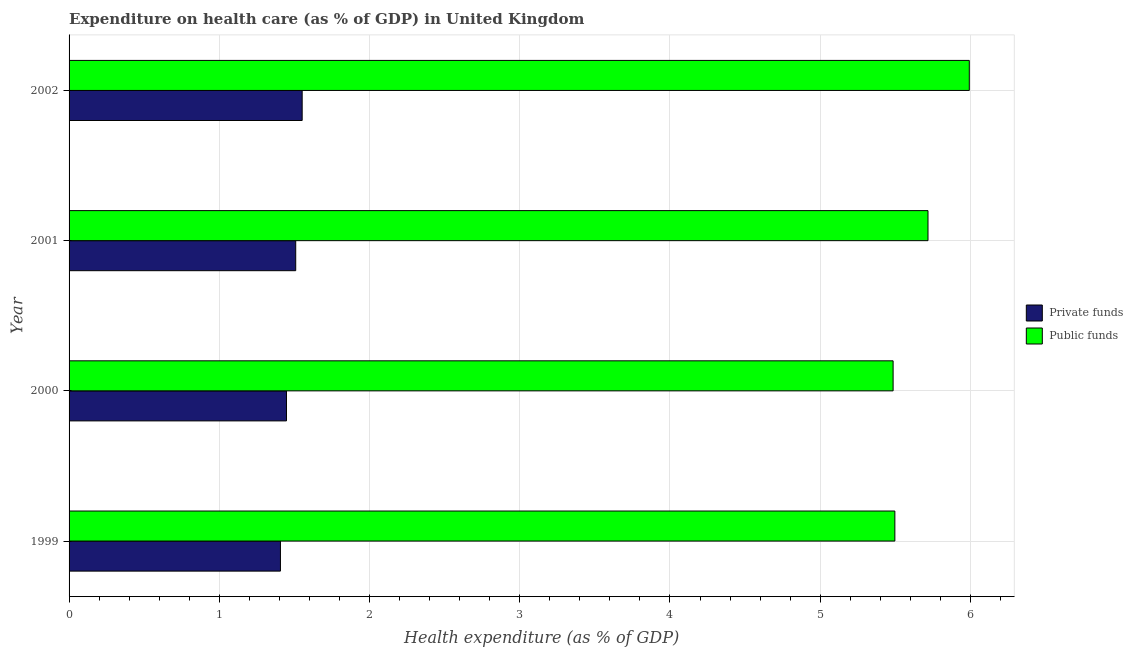How many different coloured bars are there?
Make the answer very short. 2. How many groups of bars are there?
Ensure brevity in your answer.  4. Are the number of bars on each tick of the Y-axis equal?
Make the answer very short. Yes. How many bars are there on the 4th tick from the top?
Offer a terse response. 2. How many bars are there on the 4th tick from the bottom?
Provide a short and direct response. 2. In how many cases, is the number of bars for a given year not equal to the number of legend labels?
Provide a succinct answer. 0. What is the amount of private funds spent in healthcare in 2001?
Offer a terse response. 1.51. Across all years, what is the maximum amount of public funds spent in healthcare?
Your answer should be compact. 5.99. Across all years, what is the minimum amount of public funds spent in healthcare?
Keep it short and to the point. 5.49. In which year was the amount of private funds spent in healthcare maximum?
Your answer should be very brief. 2002. What is the total amount of private funds spent in healthcare in the graph?
Offer a very short reply. 5.91. What is the difference between the amount of private funds spent in healthcare in 2000 and that in 2001?
Offer a very short reply. -0.06. What is the difference between the amount of private funds spent in healthcare in 1999 and the amount of public funds spent in healthcare in 2000?
Keep it short and to the point. -4.08. What is the average amount of private funds spent in healthcare per year?
Your answer should be compact. 1.48. In the year 1999, what is the difference between the amount of private funds spent in healthcare and amount of public funds spent in healthcare?
Give a very brief answer. -4.09. In how many years, is the amount of private funds spent in healthcare greater than 2.2 %?
Offer a very short reply. 0. What is the ratio of the amount of public funds spent in healthcare in 1999 to that in 2002?
Your response must be concise. 0.92. Is the amount of public funds spent in healthcare in 1999 less than that in 2002?
Offer a terse response. Yes. What is the difference between the highest and the second highest amount of private funds spent in healthcare?
Provide a short and direct response. 0.04. What is the difference between the highest and the lowest amount of private funds spent in healthcare?
Keep it short and to the point. 0.14. In how many years, is the amount of public funds spent in healthcare greater than the average amount of public funds spent in healthcare taken over all years?
Your response must be concise. 2. Is the sum of the amount of private funds spent in healthcare in 1999 and 2001 greater than the maximum amount of public funds spent in healthcare across all years?
Offer a terse response. No. What does the 2nd bar from the top in 2002 represents?
Your answer should be very brief. Private funds. What does the 2nd bar from the bottom in 1999 represents?
Your answer should be compact. Public funds. How many years are there in the graph?
Keep it short and to the point. 4. What is the difference between two consecutive major ticks on the X-axis?
Ensure brevity in your answer.  1. Are the values on the major ticks of X-axis written in scientific E-notation?
Ensure brevity in your answer.  No. Does the graph contain any zero values?
Offer a very short reply. No. Where does the legend appear in the graph?
Ensure brevity in your answer.  Center right. What is the title of the graph?
Your response must be concise. Expenditure on health care (as % of GDP) in United Kingdom. What is the label or title of the X-axis?
Keep it short and to the point. Health expenditure (as % of GDP). What is the label or title of the Y-axis?
Your answer should be very brief. Year. What is the Health expenditure (as % of GDP) in Private funds in 1999?
Offer a very short reply. 1.41. What is the Health expenditure (as % of GDP) of Public funds in 1999?
Give a very brief answer. 5.5. What is the Health expenditure (as % of GDP) in Private funds in 2000?
Your response must be concise. 1.45. What is the Health expenditure (as % of GDP) of Public funds in 2000?
Provide a succinct answer. 5.49. What is the Health expenditure (as % of GDP) of Private funds in 2001?
Provide a short and direct response. 1.51. What is the Health expenditure (as % of GDP) of Public funds in 2001?
Your answer should be compact. 5.72. What is the Health expenditure (as % of GDP) in Private funds in 2002?
Offer a terse response. 1.55. What is the Health expenditure (as % of GDP) in Public funds in 2002?
Offer a terse response. 5.99. Across all years, what is the maximum Health expenditure (as % of GDP) in Private funds?
Your answer should be very brief. 1.55. Across all years, what is the maximum Health expenditure (as % of GDP) of Public funds?
Keep it short and to the point. 5.99. Across all years, what is the minimum Health expenditure (as % of GDP) in Private funds?
Make the answer very short. 1.41. Across all years, what is the minimum Health expenditure (as % of GDP) in Public funds?
Give a very brief answer. 5.49. What is the total Health expenditure (as % of GDP) in Private funds in the graph?
Give a very brief answer. 5.91. What is the total Health expenditure (as % of GDP) in Public funds in the graph?
Give a very brief answer. 22.69. What is the difference between the Health expenditure (as % of GDP) of Private funds in 1999 and that in 2000?
Provide a short and direct response. -0.04. What is the difference between the Health expenditure (as % of GDP) in Public funds in 1999 and that in 2000?
Your answer should be very brief. 0.01. What is the difference between the Health expenditure (as % of GDP) in Private funds in 1999 and that in 2001?
Give a very brief answer. -0.1. What is the difference between the Health expenditure (as % of GDP) in Public funds in 1999 and that in 2001?
Provide a succinct answer. -0.22. What is the difference between the Health expenditure (as % of GDP) in Private funds in 1999 and that in 2002?
Your response must be concise. -0.14. What is the difference between the Health expenditure (as % of GDP) of Public funds in 1999 and that in 2002?
Your response must be concise. -0.5. What is the difference between the Health expenditure (as % of GDP) in Private funds in 2000 and that in 2001?
Offer a very short reply. -0.06. What is the difference between the Health expenditure (as % of GDP) in Public funds in 2000 and that in 2001?
Your response must be concise. -0.23. What is the difference between the Health expenditure (as % of GDP) in Private funds in 2000 and that in 2002?
Your answer should be very brief. -0.1. What is the difference between the Health expenditure (as % of GDP) of Public funds in 2000 and that in 2002?
Provide a succinct answer. -0.51. What is the difference between the Health expenditure (as % of GDP) in Private funds in 2001 and that in 2002?
Your response must be concise. -0.04. What is the difference between the Health expenditure (as % of GDP) of Public funds in 2001 and that in 2002?
Your response must be concise. -0.27. What is the difference between the Health expenditure (as % of GDP) of Private funds in 1999 and the Health expenditure (as % of GDP) of Public funds in 2000?
Your response must be concise. -4.08. What is the difference between the Health expenditure (as % of GDP) of Private funds in 1999 and the Health expenditure (as % of GDP) of Public funds in 2001?
Your answer should be compact. -4.31. What is the difference between the Health expenditure (as % of GDP) of Private funds in 1999 and the Health expenditure (as % of GDP) of Public funds in 2002?
Provide a short and direct response. -4.59. What is the difference between the Health expenditure (as % of GDP) of Private funds in 2000 and the Health expenditure (as % of GDP) of Public funds in 2001?
Provide a short and direct response. -4.27. What is the difference between the Health expenditure (as % of GDP) of Private funds in 2000 and the Health expenditure (as % of GDP) of Public funds in 2002?
Ensure brevity in your answer.  -4.55. What is the difference between the Health expenditure (as % of GDP) in Private funds in 2001 and the Health expenditure (as % of GDP) in Public funds in 2002?
Provide a succinct answer. -4.48. What is the average Health expenditure (as % of GDP) in Private funds per year?
Ensure brevity in your answer.  1.48. What is the average Health expenditure (as % of GDP) of Public funds per year?
Give a very brief answer. 5.67. In the year 1999, what is the difference between the Health expenditure (as % of GDP) of Private funds and Health expenditure (as % of GDP) of Public funds?
Your response must be concise. -4.09. In the year 2000, what is the difference between the Health expenditure (as % of GDP) in Private funds and Health expenditure (as % of GDP) in Public funds?
Provide a succinct answer. -4.04. In the year 2001, what is the difference between the Health expenditure (as % of GDP) of Private funds and Health expenditure (as % of GDP) of Public funds?
Offer a terse response. -4.21. In the year 2002, what is the difference between the Health expenditure (as % of GDP) in Private funds and Health expenditure (as % of GDP) in Public funds?
Provide a short and direct response. -4.44. What is the ratio of the Health expenditure (as % of GDP) of Private funds in 1999 to that in 2000?
Your answer should be compact. 0.97. What is the ratio of the Health expenditure (as % of GDP) in Private funds in 1999 to that in 2001?
Your response must be concise. 0.93. What is the ratio of the Health expenditure (as % of GDP) in Public funds in 1999 to that in 2001?
Provide a succinct answer. 0.96. What is the ratio of the Health expenditure (as % of GDP) of Private funds in 1999 to that in 2002?
Offer a terse response. 0.91. What is the ratio of the Health expenditure (as % of GDP) in Public funds in 1999 to that in 2002?
Ensure brevity in your answer.  0.92. What is the ratio of the Health expenditure (as % of GDP) of Private funds in 2000 to that in 2001?
Offer a terse response. 0.96. What is the ratio of the Health expenditure (as % of GDP) in Public funds in 2000 to that in 2001?
Provide a short and direct response. 0.96. What is the ratio of the Health expenditure (as % of GDP) in Private funds in 2000 to that in 2002?
Make the answer very short. 0.93. What is the ratio of the Health expenditure (as % of GDP) in Public funds in 2000 to that in 2002?
Give a very brief answer. 0.92. What is the ratio of the Health expenditure (as % of GDP) of Private funds in 2001 to that in 2002?
Offer a terse response. 0.97. What is the ratio of the Health expenditure (as % of GDP) in Public funds in 2001 to that in 2002?
Offer a terse response. 0.95. What is the difference between the highest and the second highest Health expenditure (as % of GDP) of Private funds?
Ensure brevity in your answer.  0.04. What is the difference between the highest and the second highest Health expenditure (as % of GDP) of Public funds?
Your response must be concise. 0.27. What is the difference between the highest and the lowest Health expenditure (as % of GDP) in Private funds?
Offer a very short reply. 0.14. What is the difference between the highest and the lowest Health expenditure (as % of GDP) of Public funds?
Provide a short and direct response. 0.51. 